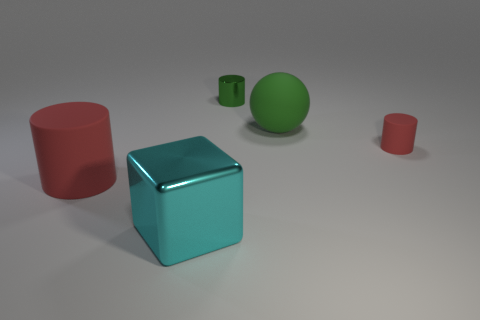Subtract all brown cylinders. Subtract all yellow blocks. How many cylinders are left? 3 Add 4 red matte cylinders. How many objects exist? 9 Subtract all spheres. How many objects are left? 4 Subtract all tiny metal cylinders. Subtract all big red things. How many objects are left? 3 Add 4 rubber cylinders. How many rubber cylinders are left? 6 Add 3 small gray shiny things. How many small gray shiny things exist? 3 Subtract 0 blue spheres. How many objects are left? 5 